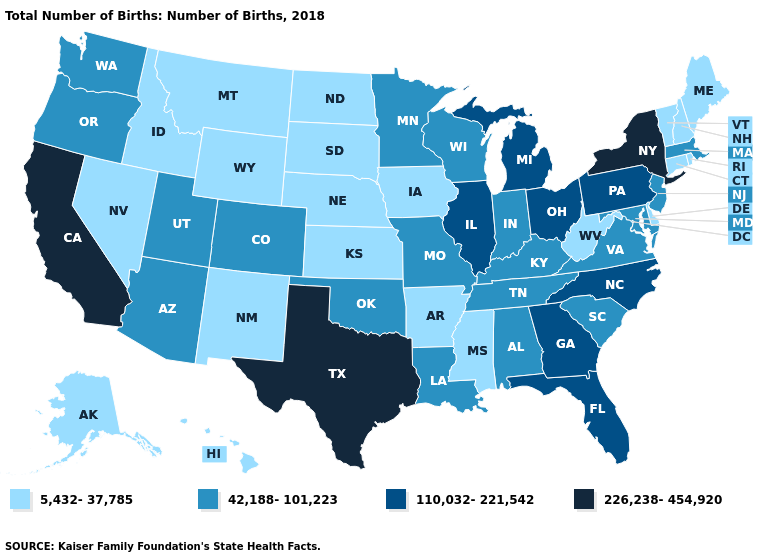Name the states that have a value in the range 5,432-37,785?
Concise answer only. Alaska, Arkansas, Connecticut, Delaware, Hawaii, Idaho, Iowa, Kansas, Maine, Mississippi, Montana, Nebraska, Nevada, New Hampshire, New Mexico, North Dakota, Rhode Island, South Dakota, Vermont, West Virginia, Wyoming. What is the value of Illinois?
Quick response, please. 110,032-221,542. What is the value of Pennsylvania?
Give a very brief answer. 110,032-221,542. Which states have the lowest value in the South?
Give a very brief answer. Arkansas, Delaware, Mississippi, West Virginia. What is the value of Hawaii?
Concise answer only. 5,432-37,785. What is the value of Virginia?
Write a very short answer. 42,188-101,223. Name the states that have a value in the range 110,032-221,542?
Concise answer only. Florida, Georgia, Illinois, Michigan, North Carolina, Ohio, Pennsylvania. Name the states that have a value in the range 42,188-101,223?
Short answer required. Alabama, Arizona, Colorado, Indiana, Kentucky, Louisiana, Maryland, Massachusetts, Minnesota, Missouri, New Jersey, Oklahoma, Oregon, South Carolina, Tennessee, Utah, Virginia, Washington, Wisconsin. Does the map have missing data?
Give a very brief answer. No. Does the first symbol in the legend represent the smallest category?
Keep it brief. Yes. Among the states that border New Hampshire , which have the highest value?
Short answer required. Massachusetts. How many symbols are there in the legend?
Quick response, please. 4. What is the highest value in the USA?
Write a very short answer. 226,238-454,920. Among the states that border Wyoming , does Idaho have the highest value?
Short answer required. No. Name the states that have a value in the range 42,188-101,223?
Short answer required. Alabama, Arizona, Colorado, Indiana, Kentucky, Louisiana, Maryland, Massachusetts, Minnesota, Missouri, New Jersey, Oklahoma, Oregon, South Carolina, Tennessee, Utah, Virginia, Washington, Wisconsin. 